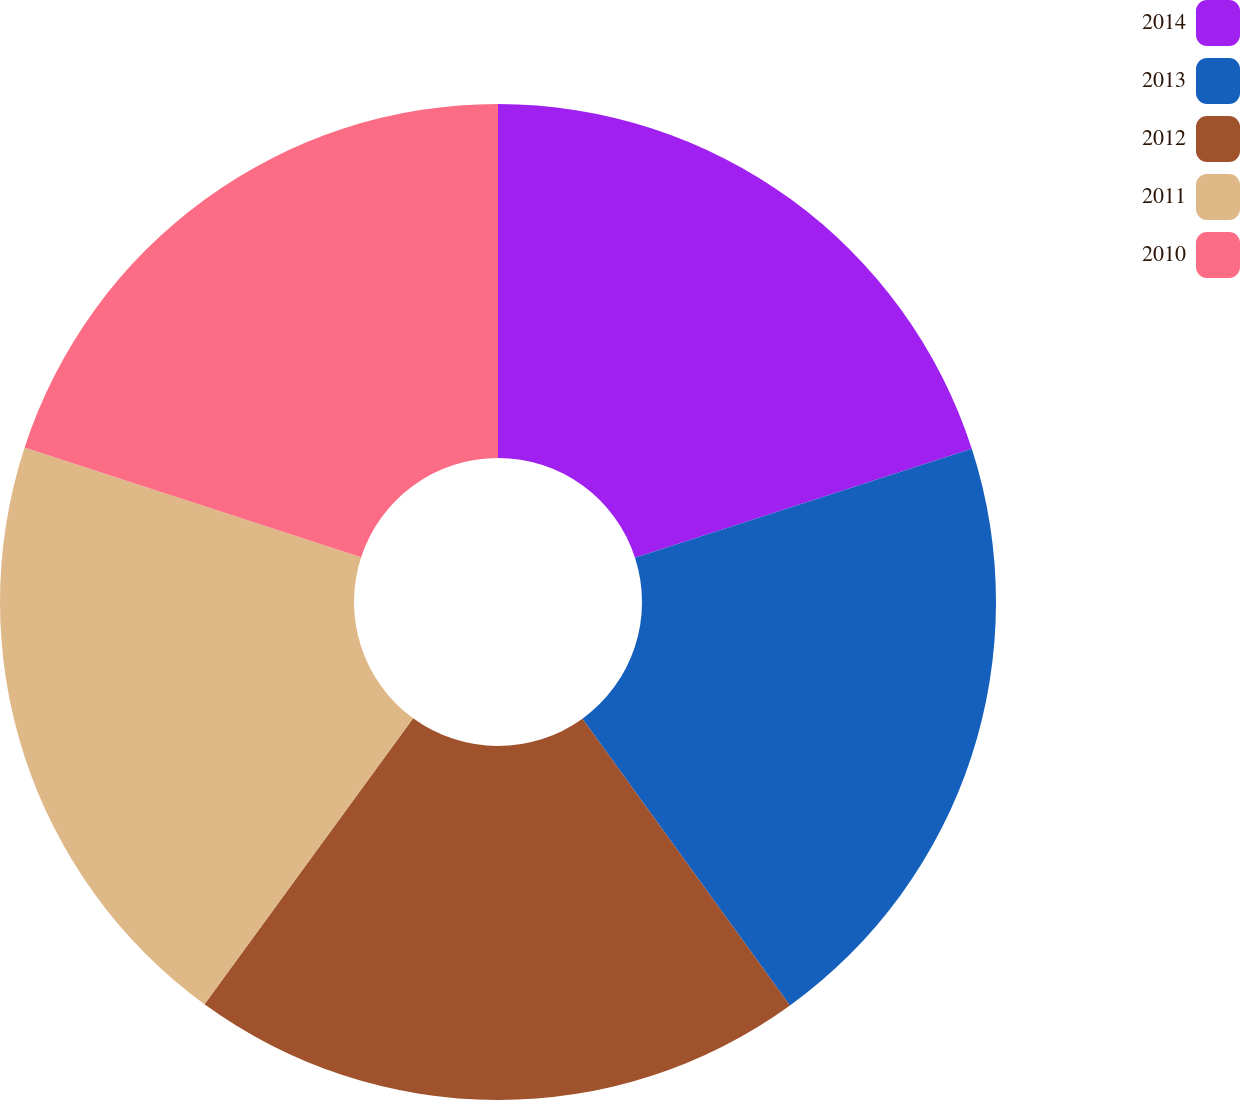Convert chart. <chart><loc_0><loc_0><loc_500><loc_500><pie_chart><fcel>2014<fcel>2013<fcel>2012<fcel>2011<fcel>2010<nl><fcel>20.02%<fcel>20.01%<fcel>20.0%<fcel>19.99%<fcel>19.98%<nl></chart> 